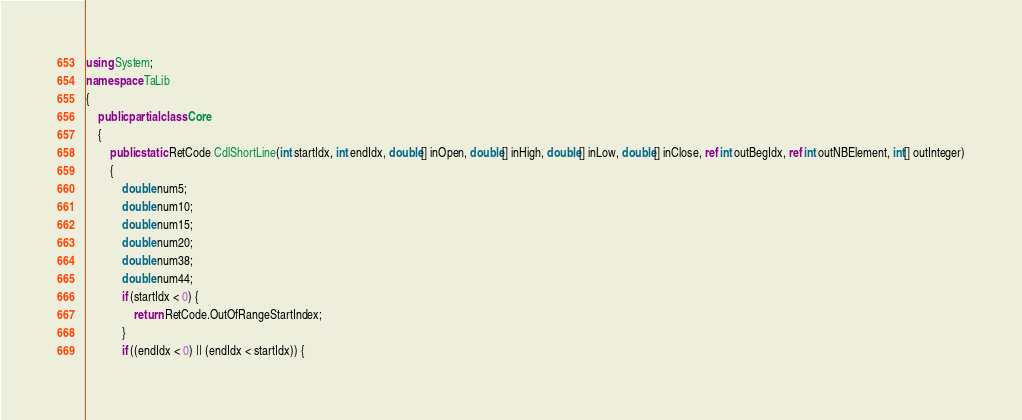<code> <loc_0><loc_0><loc_500><loc_500><_C#_>using System;
namespace TaLib
{
    public partial class Core
    {
        public static RetCode CdlShortLine(int startIdx, int endIdx, double[] inOpen, double[] inHigh, double[] inLow, double[] inClose, ref int outBegIdx, ref int outNBElement, int[] outInteger)
        {
            double num5;
            double num10;
            double num15;
            double num20;
            double num38;
            double num44;
            if (startIdx < 0) {
                return RetCode.OutOfRangeStartIndex;
            }
            if ((endIdx < 0) || (endIdx < startIdx)) {</code> 